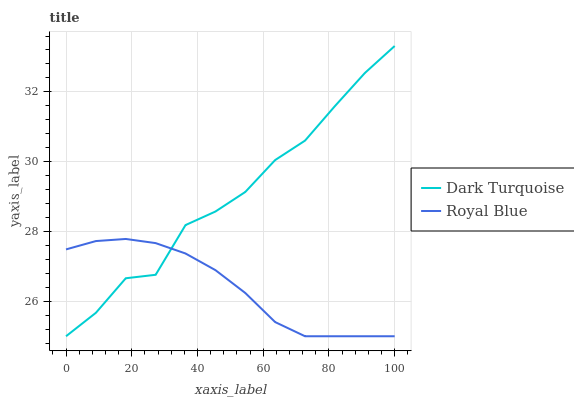Does Royal Blue have the minimum area under the curve?
Answer yes or no. Yes. Does Dark Turquoise have the maximum area under the curve?
Answer yes or no. Yes. Does Royal Blue have the maximum area under the curve?
Answer yes or no. No. Is Royal Blue the smoothest?
Answer yes or no. Yes. Is Dark Turquoise the roughest?
Answer yes or no. Yes. Is Royal Blue the roughest?
Answer yes or no. No. Does Dark Turquoise have the lowest value?
Answer yes or no. Yes. Does Dark Turquoise have the highest value?
Answer yes or no. Yes. Does Royal Blue have the highest value?
Answer yes or no. No. Does Royal Blue intersect Dark Turquoise?
Answer yes or no. Yes. Is Royal Blue less than Dark Turquoise?
Answer yes or no. No. Is Royal Blue greater than Dark Turquoise?
Answer yes or no. No. 